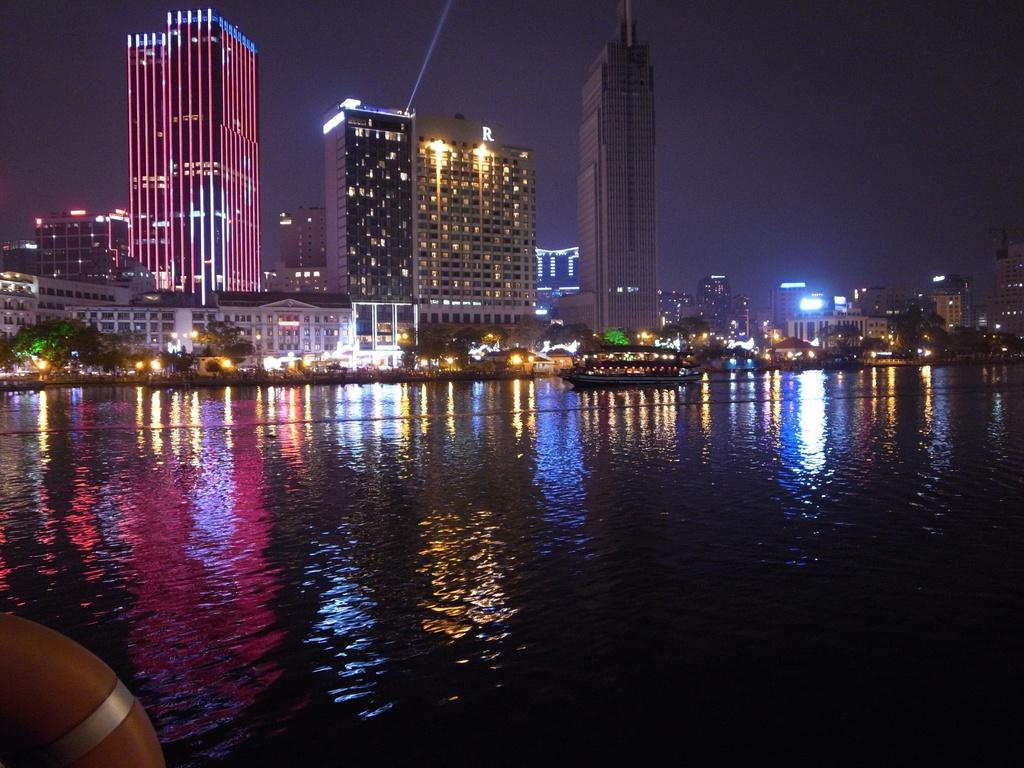What is the main object in the image related to water activities? There is a swim tube in the image. What is the setting of the image? There is a boat on water in the image, and buildings and trees are visible. Are there any artificial light sources in the image? Yes, there are lights in the image. What can be seen in the background of the image? The sky is visible in the background of the image. How many eggs are being smashed by the dad in the image? There is no dad or eggs present in the image. 